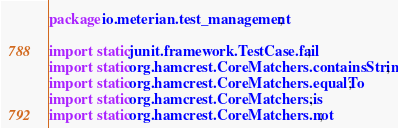<code> <loc_0><loc_0><loc_500><loc_500><_Java_>package io.meterian.test_management;

import static junit.framework.TestCase.fail;
import static org.hamcrest.CoreMatchers.containsString;
import static org.hamcrest.CoreMatchers.equalTo;
import static org.hamcrest.CoreMatchers.is;
import static org.hamcrest.CoreMatchers.not;</code> 